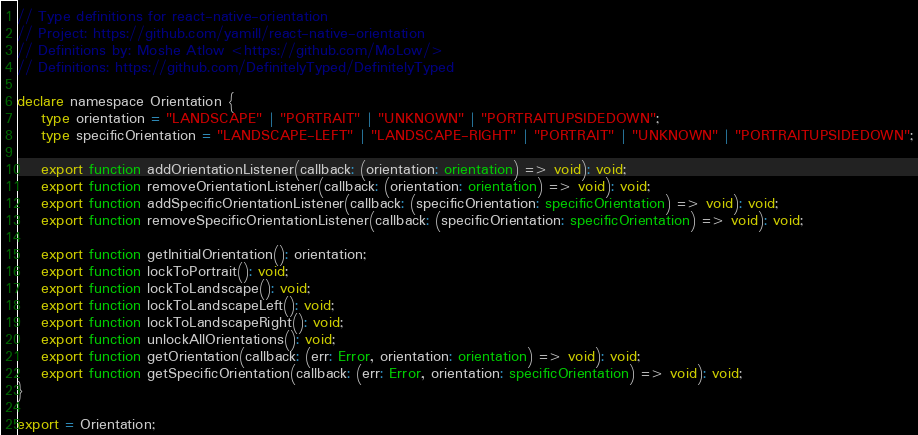Convert code to text. <code><loc_0><loc_0><loc_500><loc_500><_TypeScript_>// Type definitions for react-native-orientation
// Project: https://github.com/yamill/react-native-orientation
// Definitions by: Moshe Atlow <https://github.com/MoLow/>
// Definitions: https://github.com/DefinitelyTyped/DefinitelyTyped

declare namespace Orientation {
    type orientation = "LANDSCAPE" | "PORTRAIT" | "UNKNOWN" | "PORTRAITUPSIDEDOWN";
    type specificOrientation = "LANDSCAPE-LEFT" | "LANDSCAPE-RIGHT" | "PORTRAIT" | "UNKNOWN" | "PORTRAITUPSIDEDOWN";

    export function addOrientationListener(callback: (orientation: orientation) => void): void;
    export function removeOrientationListener(callback: (orientation: orientation) => void): void;
    export function addSpecificOrientationListener(callback: (specificOrientation: specificOrientation) => void): void;
    export function removeSpecificOrientationListener(callback: (specificOrientation: specificOrientation) => void): void;

    export function getInitialOrientation(): orientation;
    export function lockToPortrait(): void;
    export function lockToLandscape(): void;
    export function lockToLandscapeLeft(): void;
    export function lockToLandscapeRight(): void;
    export function unlockAllOrientations(): void;
    export function getOrientation(callback: (err: Error, orientation: orientation) => void): void;
    export function getSpecificOrientation(callback: (err: Error, orientation: specificOrientation) => void): void;
}

export = Orientation;
</code> 